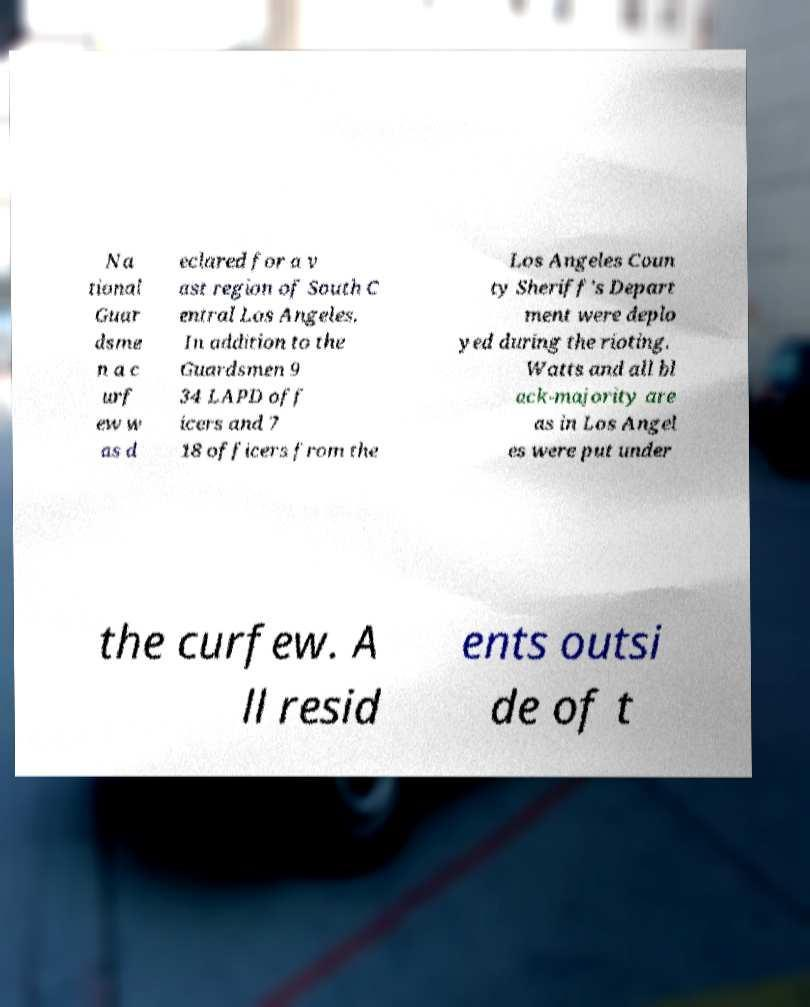Please read and relay the text visible in this image. What does it say? Na tional Guar dsme n a c urf ew w as d eclared for a v ast region of South C entral Los Angeles. In addition to the Guardsmen 9 34 LAPD off icers and 7 18 officers from the Los Angeles Coun ty Sheriff's Depart ment were deplo yed during the rioting. Watts and all bl ack-majority are as in Los Angel es were put under the curfew. A ll resid ents outsi de of t 